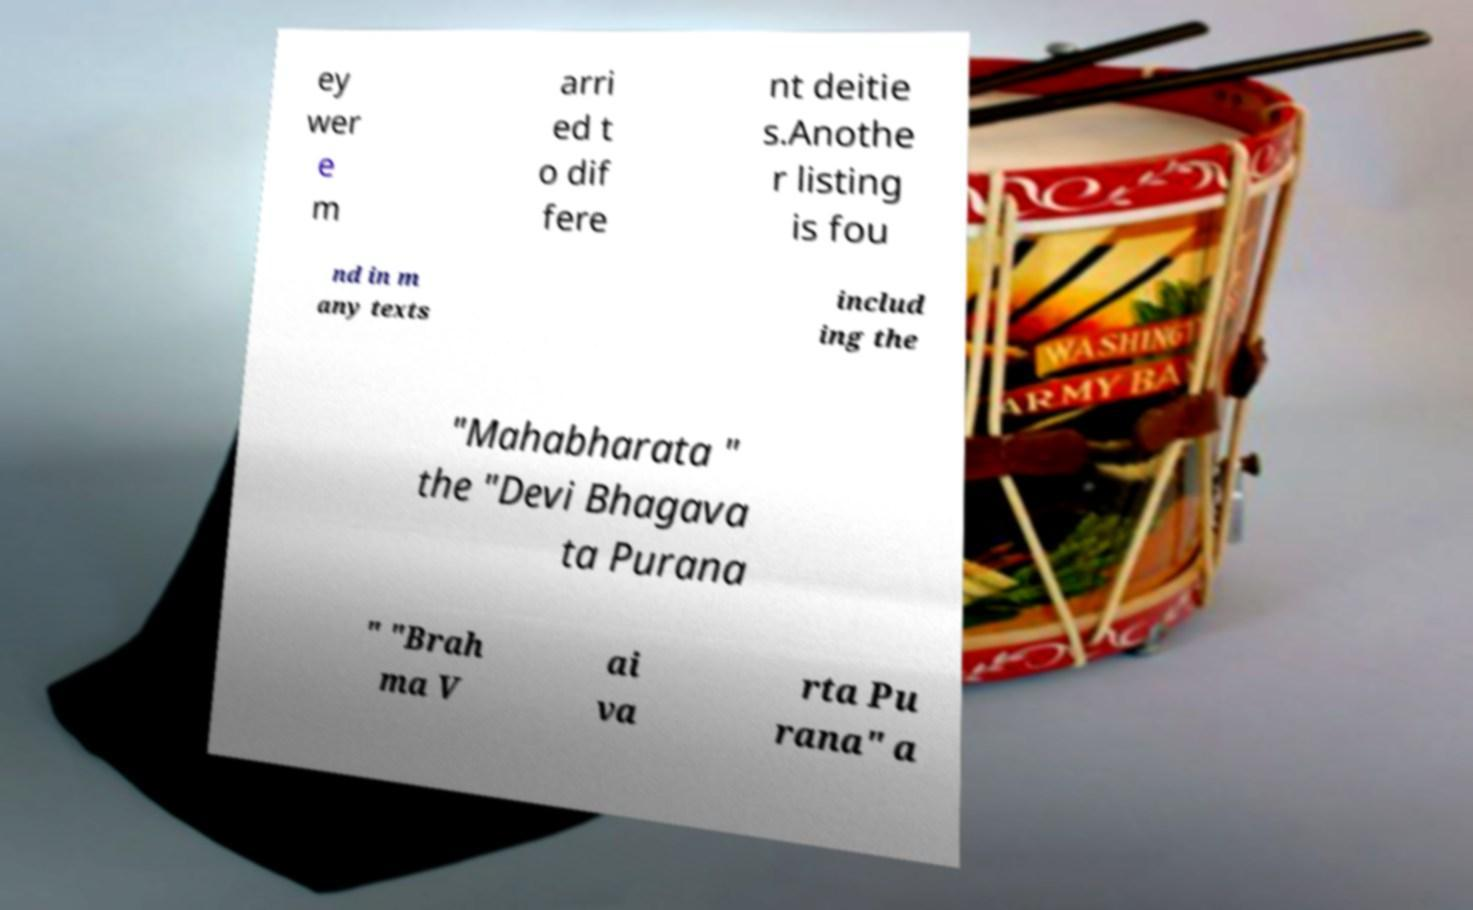I need the written content from this picture converted into text. Can you do that? ey wer e m arri ed t o dif fere nt deitie s.Anothe r listing is fou nd in m any texts includ ing the "Mahabharata " the "Devi Bhagava ta Purana " "Brah ma V ai va rta Pu rana" a 